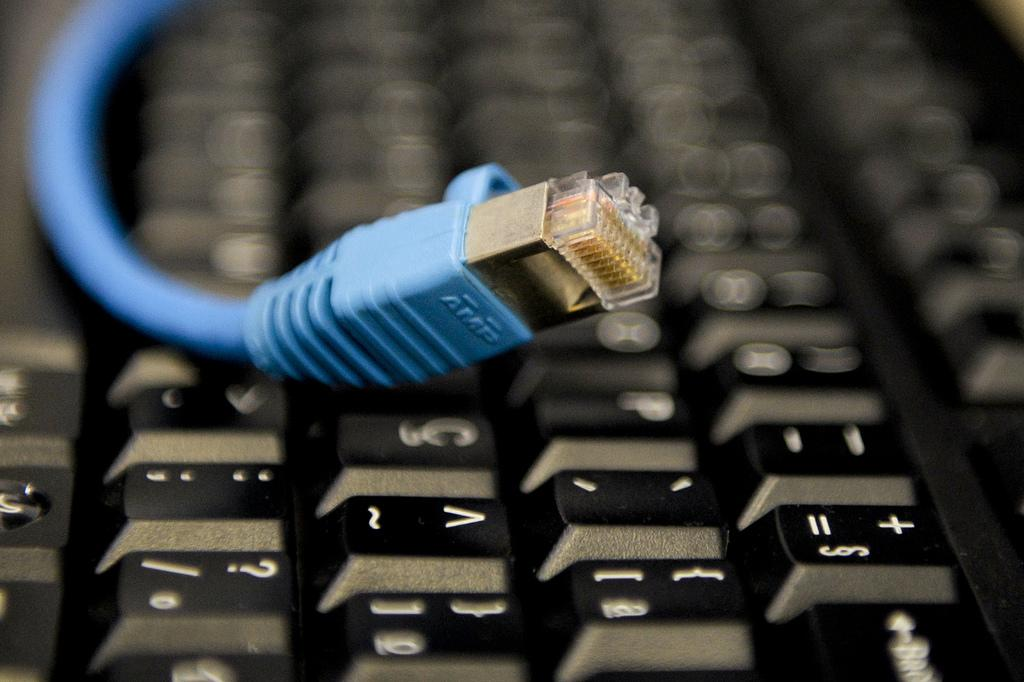What electronic device is visible in the image? There is a keyboard in the image. Is there any additional equipment connected to the keyboard? Yes, there is a LAN cable on the keyboard. What type of jelly is being used to hold the keyboard in place in the image? There is no jelly present in the image, and the keyboard is not being held in place by any jelly. 